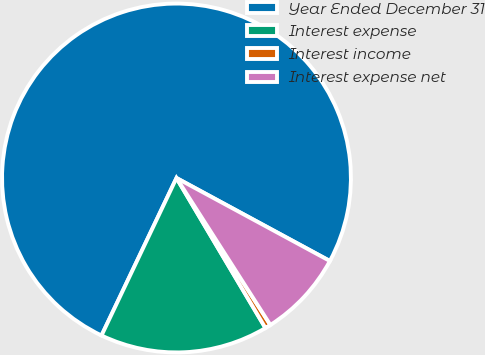Convert chart. <chart><loc_0><loc_0><loc_500><loc_500><pie_chart><fcel>Year Ended December 31<fcel>Interest expense<fcel>Interest income<fcel>Interest expense net<nl><fcel>75.83%<fcel>15.59%<fcel>0.53%<fcel>8.06%<nl></chart> 